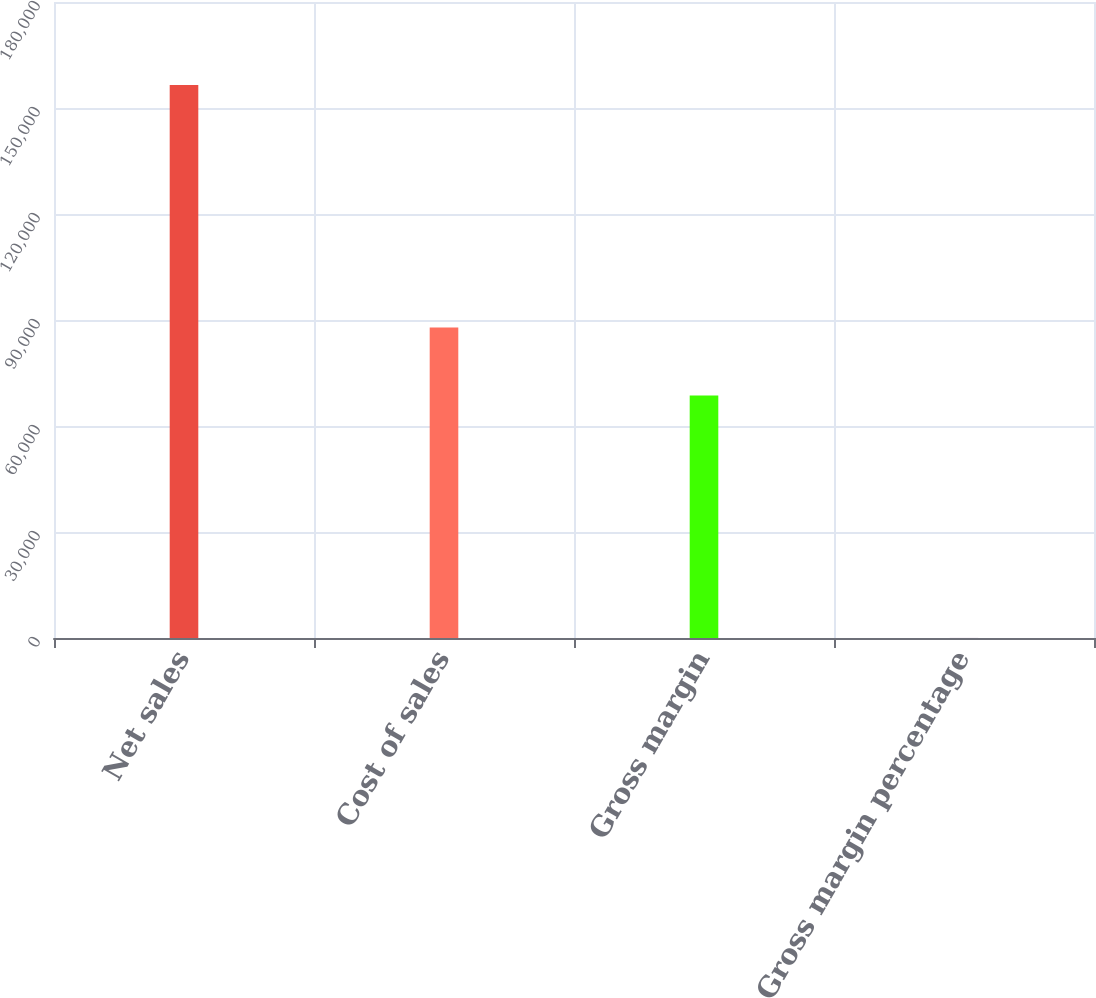<chart> <loc_0><loc_0><loc_500><loc_500><bar_chart><fcel>Net sales<fcel>Cost of sales<fcel>Gross margin<fcel>Gross margin percentage<nl><fcel>156508<fcel>87846<fcel>68662<fcel>43.9<nl></chart> 